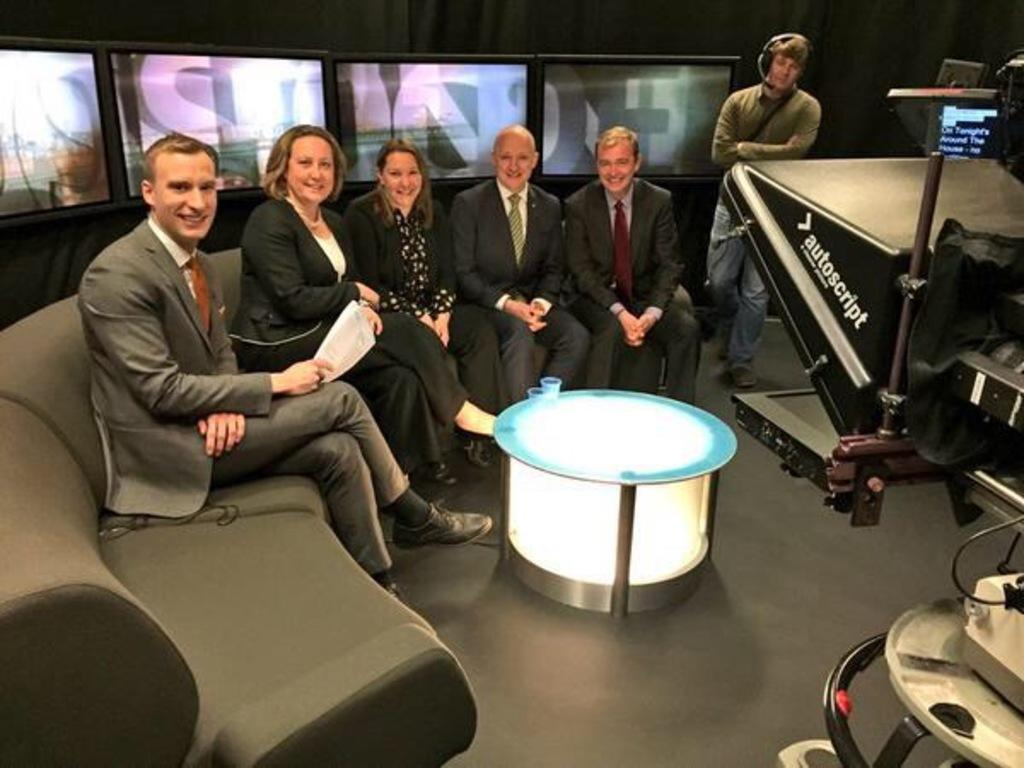What are the people in the image doing? The people in the image are sitting on a sofa. What is in front of the group of people? There is a table in front of the group of people. Can you describe the person in the background? There is another person standing in the background. How many babies are crawling on the floor in the image? There are no babies present in the image. What type of pin is holding the person's clothes together in the image? There is no pin visible in the image. 